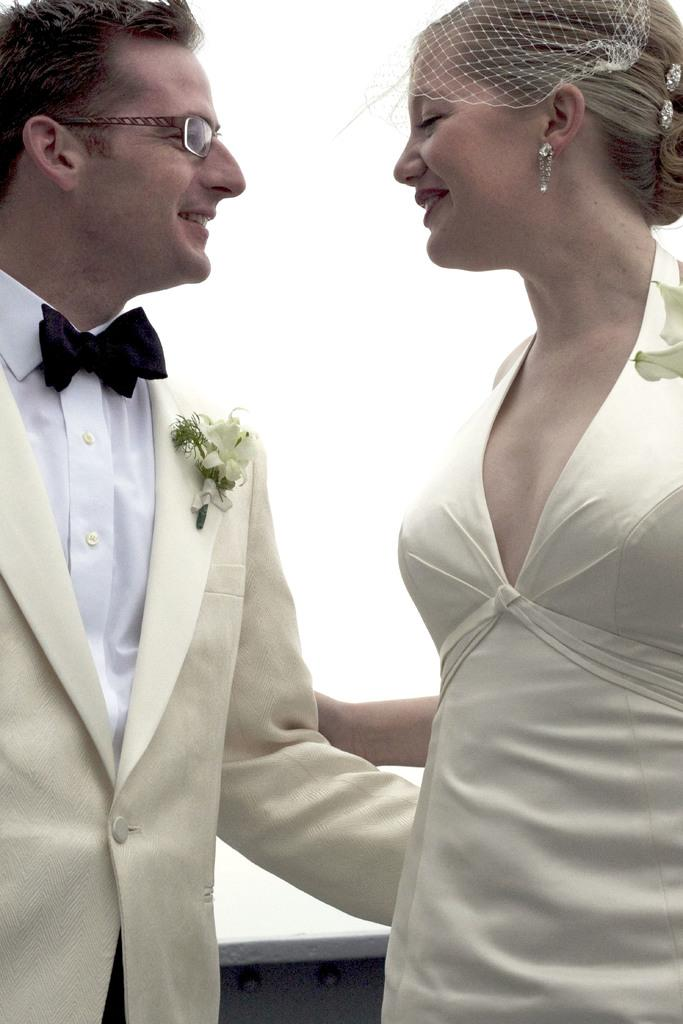What is the man in the image wearing? The man is wearing a cream-colored suit and a white shirt. What is the bride in the image wearing? The bride is wearing a cream-colored top. What are the man and the bride doing in the image? The man is holding the bride's hand. What is the color of the background in the image? The background in the image is white. How many people are camping in the image? There is no camping or crowd present in the image; it features a man and a bride holding hands. What type of ring is the bride wearing on her finger in the image? There is no ring visible on the bride's finger in the image. 